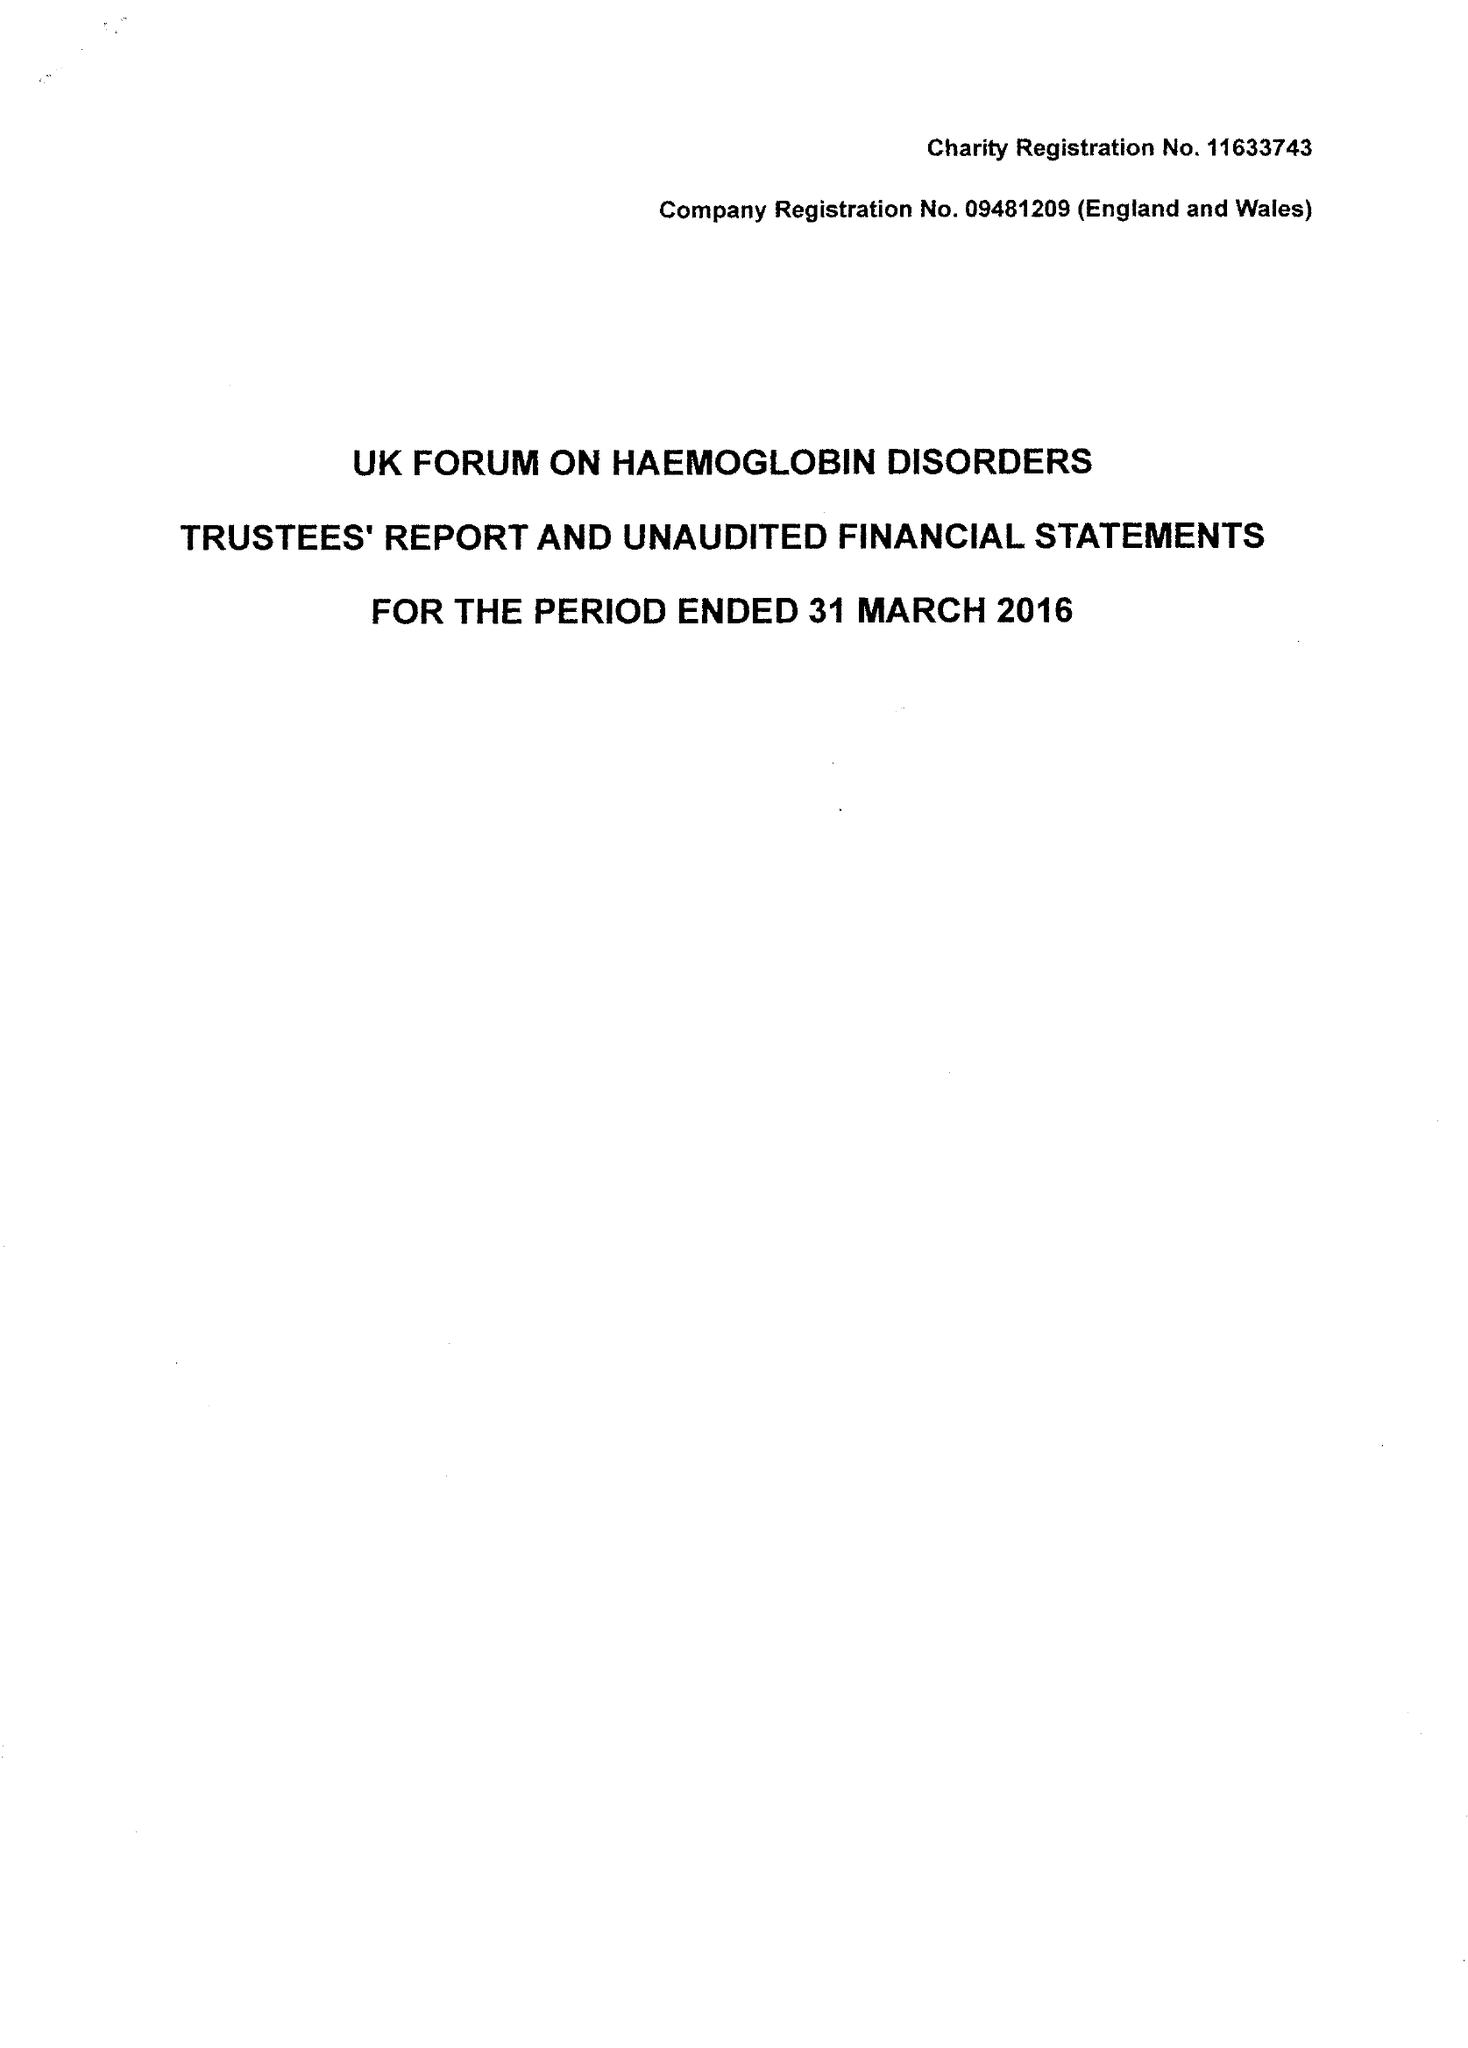What is the value for the spending_annually_in_british_pounds?
Answer the question using a single word or phrase. 62977.00 